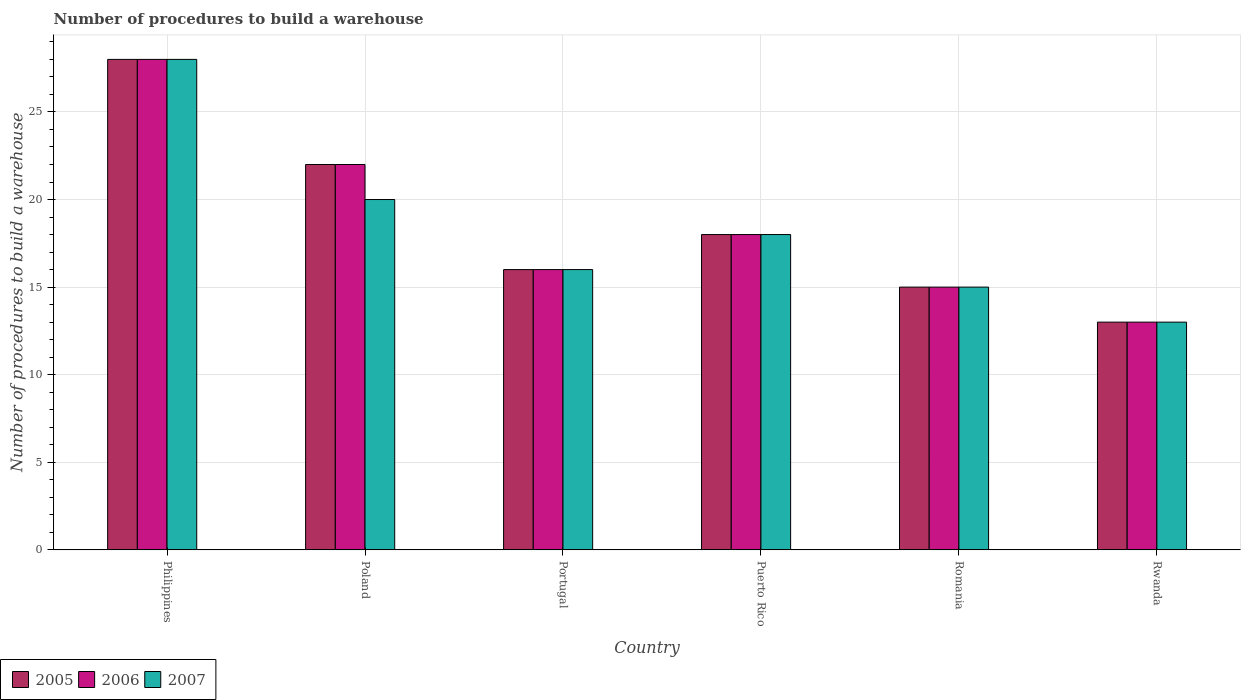How many groups of bars are there?
Make the answer very short. 6. What is the label of the 5th group of bars from the left?
Provide a succinct answer. Romania. Across all countries, what is the minimum number of procedures to build a warehouse in in 2005?
Provide a short and direct response. 13. In which country was the number of procedures to build a warehouse in in 2006 minimum?
Offer a terse response. Rwanda. What is the total number of procedures to build a warehouse in in 2005 in the graph?
Give a very brief answer. 112. What is the difference between the number of procedures to build a warehouse in in 2006 in Portugal and that in Romania?
Provide a succinct answer. 1. What is the difference between the number of procedures to build a warehouse in in 2007 in Puerto Rico and the number of procedures to build a warehouse in in 2006 in Romania?
Offer a very short reply. 3. What is the average number of procedures to build a warehouse in in 2006 per country?
Your answer should be compact. 18.67. In how many countries, is the number of procedures to build a warehouse in in 2005 greater than 24?
Provide a succinct answer. 1. In how many countries, is the number of procedures to build a warehouse in in 2006 greater than the average number of procedures to build a warehouse in in 2006 taken over all countries?
Offer a terse response. 2. What does the 1st bar from the left in Portugal represents?
Your answer should be very brief. 2005. What does the 3rd bar from the right in Romania represents?
Your response must be concise. 2005. How many bars are there?
Provide a short and direct response. 18. What is the difference between two consecutive major ticks on the Y-axis?
Ensure brevity in your answer.  5. Are the values on the major ticks of Y-axis written in scientific E-notation?
Your response must be concise. No. Does the graph contain grids?
Offer a terse response. Yes. Where does the legend appear in the graph?
Make the answer very short. Bottom left. What is the title of the graph?
Keep it short and to the point. Number of procedures to build a warehouse. What is the label or title of the X-axis?
Your answer should be compact. Country. What is the label or title of the Y-axis?
Give a very brief answer. Number of procedures to build a warehouse. What is the Number of procedures to build a warehouse of 2005 in Philippines?
Your answer should be compact. 28. What is the Number of procedures to build a warehouse in 2006 in Philippines?
Provide a short and direct response. 28. What is the Number of procedures to build a warehouse of 2005 in Poland?
Provide a short and direct response. 22. What is the Number of procedures to build a warehouse of 2006 in Poland?
Keep it short and to the point. 22. What is the Number of procedures to build a warehouse of 2006 in Portugal?
Ensure brevity in your answer.  16. What is the Number of procedures to build a warehouse in 2007 in Portugal?
Your response must be concise. 16. What is the Number of procedures to build a warehouse in 2006 in Puerto Rico?
Offer a very short reply. 18. What is the Number of procedures to build a warehouse in 2005 in Romania?
Offer a terse response. 15. What is the Number of procedures to build a warehouse in 2006 in Romania?
Ensure brevity in your answer.  15. What is the Number of procedures to build a warehouse of 2005 in Rwanda?
Your answer should be very brief. 13. Across all countries, what is the maximum Number of procedures to build a warehouse in 2005?
Make the answer very short. 28. Across all countries, what is the maximum Number of procedures to build a warehouse in 2007?
Your answer should be compact. 28. Across all countries, what is the minimum Number of procedures to build a warehouse in 2005?
Your answer should be compact. 13. Across all countries, what is the minimum Number of procedures to build a warehouse of 2006?
Provide a succinct answer. 13. Across all countries, what is the minimum Number of procedures to build a warehouse of 2007?
Give a very brief answer. 13. What is the total Number of procedures to build a warehouse in 2005 in the graph?
Make the answer very short. 112. What is the total Number of procedures to build a warehouse of 2006 in the graph?
Make the answer very short. 112. What is the total Number of procedures to build a warehouse of 2007 in the graph?
Give a very brief answer. 110. What is the difference between the Number of procedures to build a warehouse in 2005 in Philippines and that in Poland?
Make the answer very short. 6. What is the difference between the Number of procedures to build a warehouse of 2006 in Philippines and that in Poland?
Provide a short and direct response. 6. What is the difference between the Number of procedures to build a warehouse of 2007 in Philippines and that in Poland?
Give a very brief answer. 8. What is the difference between the Number of procedures to build a warehouse in 2006 in Philippines and that in Puerto Rico?
Offer a very short reply. 10. What is the difference between the Number of procedures to build a warehouse of 2005 in Philippines and that in Romania?
Provide a short and direct response. 13. What is the difference between the Number of procedures to build a warehouse in 2006 in Philippines and that in Romania?
Your response must be concise. 13. What is the difference between the Number of procedures to build a warehouse in 2005 in Philippines and that in Rwanda?
Your answer should be compact. 15. What is the difference between the Number of procedures to build a warehouse of 2006 in Philippines and that in Rwanda?
Keep it short and to the point. 15. What is the difference between the Number of procedures to build a warehouse of 2006 in Poland and that in Portugal?
Your response must be concise. 6. What is the difference between the Number of procedures to build a warehouse of 2006 in Poland and that in Rwanda?
Provide a short and direct response. 9. What is the difference between the Number of procedures to build a warehouse of 2006 in Portugal and that in Puerto Rico?
Your answer should be compact. -2. What is the difference between the Number of procedures to build a warehouse in 2007 in Portugal and that in Romania?
Offer a very short reply. 1. What is the difference between the Number of procedures to build a warehouse in 2005 in Portugal and that in Rwanda?
Give a very brief answer. 3. What is the difference between the Number of procedures to build a warehouse of 2006 in Portugal and that in Rwanda?
Your response must be concise. 3. What is the difference between the Number of procedures to build a warehouse of 2005 in Puerto Rico and that in Romania?
Your answer should be compact. 3. What is the difference between the Number of procedures to build a warehouse in 2007 in Puerto Rico and that in Romania?
Ensure brevity in your answer.  3. What is the difference between the Number of procedures to build a warehouse of 2005 in Puerto Rico and that in Rwanda?
Provide a succinct answer. 5. What is the difference between the Number of procedures to build a warehouse of 2006 in Puerto Rico and that in Rwanda?
Your response must be concise. 5. What is the difference between the Number of procedures to build a warehouse of 2007 in Puerto Rico and that in Rwanda?
Make the answer very short. 5. What is the difference between the Number of procedures to build a warehouse in 2005 in Philippines and the Number of procedures to build a warehouse in 2006 in Poland?
Offer a very short reply. 6. What is the difference between the Number of procedures to build a warehouse in 2005 in Philippines and the Number of procedures to build a warehouse in 2007 in Poland?
Your answer should be very brief. 8. What is the difference between the Number of procedures to build a warehouse of 2006 in Philippines and the Number of procedures to build a warehouse of 2007 in Poland?
Your response must be concise. 8. What is the difference between the Number of procedures to build a warehouse of 2005 in Philippines and the Number of procedures to build a warehouse of 2007 in Puerto Rico?
Ensure brevity in your answer.  10. What is the difference between the Number of procedures to build a warehouse in 2006 in Philippines and the Number of procedures to build a warehouse in 2007 in Puerto Rico?
Offer a terse response. 10. What is the difference between the Number of procedures to build a warehouse of 2005 in Philippines and the Number of procedures to build a warehouse of 2006 in Romania?
Make the answer very short. 13. What is the difference between the Number of procedures to build a warehouse of 2006 in Philippines and the Number of procedures to build a warehouse of 2007 in Romania?
Provide a succinct answer. 13. What is the difference between the Number of procedures to build a warehouse in 2005 in Philippines and the Number of procedures to build a warehouse in 2007 in Rwanda?
Provide a short and direct response. 15. What is the difference between the Number of procedures to build a warehouse in 2005 in Poland and the Number of procedures to build a warehouse in 2006 in Portugal?
Offer a terse response. 6. What is the difference between the Number of procedures to build a warehouse of 2005 in Poland and the Number of procedures to build a warehouse of 2007 in Puerto Rico?
Your answer should be compact. 4. What is the difference between the Number of procedures to build a warehouse of 2006 in Poland and the Number of procedures to build a warehouse of 2007 in Romania?
Your answer should be very brief. 7. What is the difference between the Number of procedures to build a warehouse of 2005 in Poland and the Number of procedures to build a warehouse of 2007 in Rwanda?
Keep it short and to the point. 9. What is the difference between the Number of procedures to build a warehouse in 2005 in Portugal and the Number of procedures to build a warehouse in 2007 in Romania?
Ensure brevity in your answer.  1. What is the difference between the Number of procedures to build a warehouse of 2006 in Portugal and the Number of procedures to build a warehouse of 2007 in Romania?
Your answer should be compact. 1. What is the difference between the Number of procedures to build a warehouse of 2005 in Portugal and the Number of procedures to build a warehouse of 2006 in Rwanda?
Provide a succinct answer. 3. What is the difference between the Number of procedures to build a warehouse in 2005 in Portugal and the Number of procedures to build a warehouse in 2007 in Rwanda?
Provide a succinct answer. 3. What is the difference between the Number of procedures to build a warehouse in 2006 in Portugal and the Number of procedures to build a warehouse in 2007 in Rwanda?
Offer a very short reply. 3. What is the difference between the Number of procedures to build a warehouse in 2005 in Puerto Rico and the Number of procedures to build a warehouse in 2006 in Rwanda?
Ensure brevity in your answer.  5. What is the difference between the Number of procedures to build a warehouse in 2005 in Puerto Rico and the Number of procedures to build a warehouse in 2007 in Rwanda?
Give a very brief answer. 5. What is the difference between the Number of procedures to build a warehouse of 2005 in Romania and the Number of procedures to build a warehouse of 2007 in Rwanda?
Offer a very short reply. 2. What is the difference between the Number of procedures to build a warehouse of 2006 in Romania and the Number of procedures to build a warehouse of 2007 in Rwanda?
Your answer should be very brief. 2. What is the average Number of procedures to build a warehouse of 2005 per country?
Keep it short and to the point. 18.67. What is the average Number of procedures to build a warehouse of 2006 per country?
Ensure brevity in your answer.  18.67. What is the average Number of procedures to build a warehouse of 2007 per country?
Give a very brief answer. 18.33. What is the difference between the Number of procedures to build a warehouse of 2005 and Number of procedures to build a warehouse of 2007 in Philippines?
Your answer should be very brief. 0. What is the difference between the Number of procedures to build a warehouse in 2005 and Number of procedures to build a warehouse in 2006 in Poland?
Your response must be concise. 0. What is the difference between the Number of procedures to build a warehouse in 2005 and Number of procedures to build a warehouse in 2007 in Portugal?
Make the answer very short. 0. What is the difference between the Number of procedures to build a warehouse in 2005 and Number of procedures to build a warehouse in 2006 in Puerto Rico?
Keep it short and to the point. 0. What is the difference between the Number of procedures to build a warehouse of 2005 and Number of procedures to build a warehouse of 2006 in Romania?
Your response must be concise. 0. What is the difference between the Number of procedures to build a warehouse of 2005 and Number of procedures to build a warehouse of 2007 in Romania?
Your answer should be compact. 0. What is the difference between the Number of procedures to build a warehouse of 2006 and Number of procedures to build a warehouse of 2007 in Romania?
Offer a terse response. 0. What is the difference between the Number of procedures to build a warehouse of 2005 and Number of procedures to build a warehouse of 2006 in Rwanda?
Your answer should be compact. 0. What is the difference between the Number of procedures to build a warehouse in 2006 and Number of procedures to build a warehouse in 2007 in Rwanda?
Your answer should be very brief. 0. What is the ratio of the Number of procedures to build a warehouse of 2005 in Philippines to that in Poland?
Provide a succinct answer. 1.27. What is the ratio of the Number of procedures to build a warehouse of 2006 in Philippines to that in Poland?
Give a very brief answer. 1.27. What is the ratio of the Number of procedures to build a warehouse of 2007 in Philippines to that in Poland?
Your response must be concise. 1.4. What is the ratio of the Number of procedures to build a warehouse of 2006 in Philippines to that in Portugal?
Give a very brief answer. 1.75. What is the ratio of the Number of procedures to build a warehouse in 2007 in Philippines to that in Portugal?
Provide a short and direct response. 1.75. What is the ratio of the Number of procedures to build a warehouse of 2005 in Philippines to that in Puerto Rico?
Your answer should be very brief. 1.56. What is the ratio of the Number of procedures to build a warehouse of 2006 in Philippines to that in Puerto Rico?
Offer a terse response. 1.56. What is the ratio of the Number of procedures to build a warehouse in 2007 in Philippines to that in Puerto Rico?
Your answer should be compact. 1.56. What is the ratio of the Number of procedures to build a warehouse of 2005 in Philippines to that in Romania?
Make the answer very short. 1.87. What is the ratio of the Number of procedures to build a warehouse in 2006 in Philippines to that in Romania?
Provide a succinct answer. 1.87. What is the ratio of the Number of procedures to build a warehouse of 2007 in Philippines to that in Romania?
Ensure brevity in your answer.  1.87. What is the ratio of the Number of procedures to build a warehouse of 2005 in Philippines to that in Rwanda?
Your answer should be compact. 2.15. What is the ratio of the Number of procedures to build a warehouse in 2006 in Philippines to that in Rwanda?
Provide a succinct answer. 2.15. What is the ratio of the Number of procedures to build a warehouse in 2007 in Philippines to that in Rwanda?
Your response must be concise. 2.15. What is the ratio of the Number of procedures to build a warehouse in 2005 in Poland to that in Portugal?
Your answer should be very brief. 1.38. What is the ratio of the Number of procedures to build a warehouse in 2006 in Poland to that in Portugal?
Ensure brevity in your answer.  1.38. What is the ratio of the Number of procedures to build a warehouse in 2005 in Poland to that in Puerto Rico?
Keep it short and to the point. 1.22. What is the ratio of the Number of procedures to build a warehouse in 2006 in Poland to that in Puerto Rico?
Provide a short and direct response. 1.22. What is the ratio of the Number of procedures to build a warehouse in 2005 in Poland to that in Romania?
Give a very brief answer. 1.47. What is the ratio of the Number of procedures to build a warehouse in 2006 in Poland to that in Romania?
Ensure brevity in your answer.  1.47. What is the ratio of the Number of procedures to build a warehouse of 2005 in Poland to that in Rwanda?
Provide a short and direct response. 1.69. What is the ratio of the Number of procedures to build a warehouse in 2006 in Poland to that in Rwanda?
Provide a succinct answer. 1.69. What is the ratio of the Number of procedures to build a warehouse of 2007 in Poland to that in Rwanda?
Offer a very short reply. 1.54. What is the ratio of the Number of procedures to build a warehouse in 2006 in Portugal to that in Puerto Rico?
Provide a short and direct response. 0.89. What is the ratio of the Number of procedures to build a warehouse of 2005 in Portugal to that in Romania?
Ensure brevity in your answer.  1.07. What is the ratio of the Number of procedures to build a warehouse of 2006 in Portugal to that in Romania?
Provide a short and direct response. 1.07. What is the ratio of the Number of procedures to build a warehouse of 2007 in Portugal to that in Romania?
Offer a terse response. 1.07. What is the ratio of the Number of procedures to build a warehouse in 2005 in Portugal to that in Rwanda?
Provide a short and direct response. 1.23. What is the ratio of the Number of procedures to build a warehouse in 2006 in Portugal to that in Rwanda?
Your answer should be compact. 1.23. What is the ratio of the Number of procedures to build a warehouse in 2007 in Portugal to that in Rwanda?
Give a very brief answer. 1.23. What is the ratio of the Number of procedures to build a warehouse of 2006 in Puerto Rico to that in Romania?
Your answer should be compact. 1.2. What is the ratio of the Number of procedures to build a warehouse of 2007 in Puerto Rico to that in Romania?
Make the answer very short. 1.2. What is the ratio of the Number of procedures to build a warehouse in 2005 in Puerto Rico to that in Rwanda?
Offer a very short reply. 1.38. What is the ratio of the Number of procedures to build a warehouse of 2006 in Puerto Rico to that in Rwanda?
Keep it short and to the point. 1.38. What is the ratio of the Number of procedures to build a warehouse in 2007 in Puerto Rico to that in Rwanda?
Make the answer very short. 1.38. What is the ratio of the Number of procedures to build a warehouse of 2005 in Romania to that in Rwanda?
Keep it short and to the point. 1.15. What is the ratio of the Number of procedures to build a warehouse of 2006 in Romania to that in Rwanda?
Keep it short and to the point. 1.15. What is the ratio of the Number of procedures to build a warehouse in 2007 in Romania to that in Rwanda?
Make the answer very short. 1.15. What is the difference between the highest and the lowest Number of procedures to build a warehouse in 2005?
Give a very brief answer. 15. What is the difference between the highest and the lowest Number of procedures to build a warehouse of 2007?
Your response must be concise. 15. 